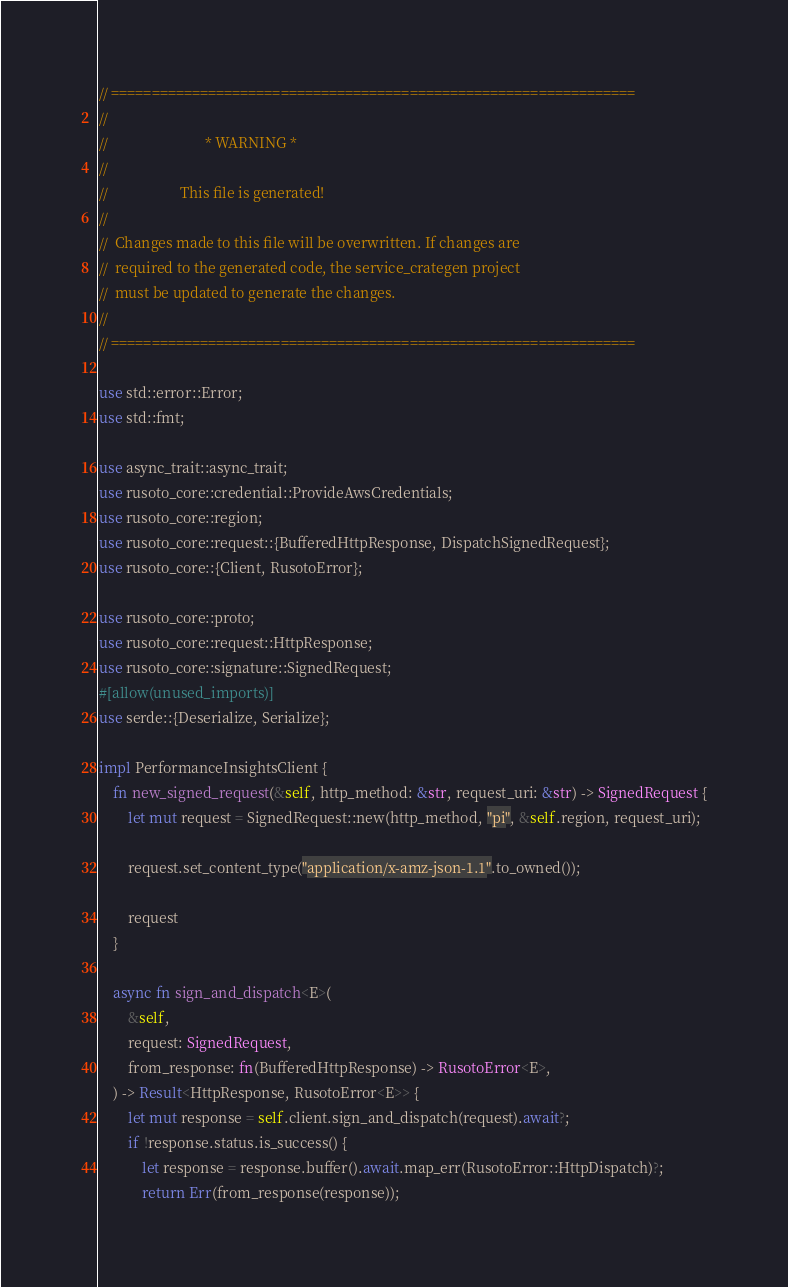Convert code to text. <code><loc_0><loc_0><loc_500><loc_500><_Rust_>// =================================================================
//
//                           * WARNING *
//
//                    This file is generated!
//
//  Changes made to this file will be overwritten. If changes are
//  required to the generated code, the service_crategen project
//  must be updated to generate the changes.
//
// =================================================================

use std::error::Error;
use std::fmt;

use async_trait::async_trait;
use rusoto_core::credential::ProvideAwsCredentials;
use rusoto_core::region;
use rusoto_core::request::{BufferedHttpResponse, DispatchSignedRequest};
use rusoto_core::{Client, RusotoError};

use rusoto_core::proto;
use rusoto_core::request::HttpResponse;
use rusoto_core::signature::SignedRequest;
#[allow(unused_imports)]
use serde::{Deserialize, Serialize};

impl PerformanceInsightsClient {
    fn new_signed_request(&self, http_method: &str, request_uri: &str) -> SignedRequest {
        let mut request = SignedRequest::new(http_method, "pi", &self.region, request_uri);

        request.set_content_type("application/x-amz-json-1.1".to_owned());

        request
    }

    async fn sign_and_dispatch<E>(
        &self,
        request: SignedRequest,
        from_response: fn(BufferedHttpResponse) -> RusotoError<E>,
    ) -> Result<HttpResponse, RusotoError<E>> {
        let mut response = self.client.sign_and_dispatch(request).await?;
        if !response.status.is_success() {
            let response = response.buffer().await.map_err(RusotoError::HttpDispatch)?;
            return Err(from_response(response));</code> 